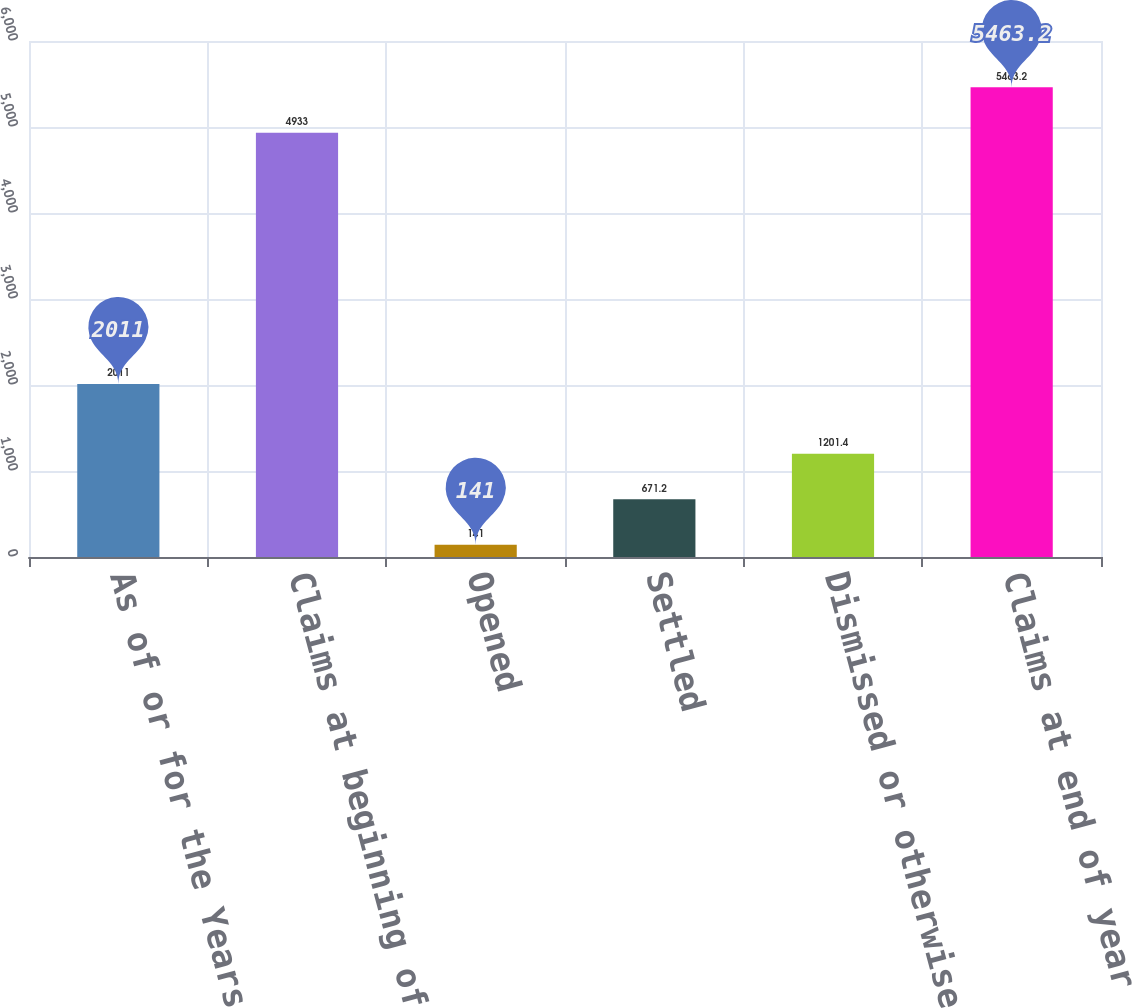Convert chart. <chart><loc_0><loc_0><loc_500><loc_500><bar_chart><fcel>As of or for the Years<fcel>Claims at beginning of year<fcel>Opened<fcel>Settled<fcel>Dismissed or otherwise<fcel>Claims at end of year<nl><fcel>2011<fcel>4933<fcel>141<fcel>671.2<fcel>1201.4<fcel>5463.2<nl></chart> 